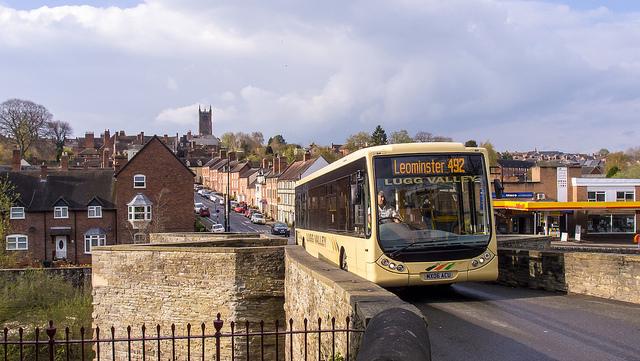Are the bus headlights illuminated?
Concise answer only. Yes. How many rooftops are visible?
Quick response, please. Yes. Is this in America?
Concise answer only. No. 